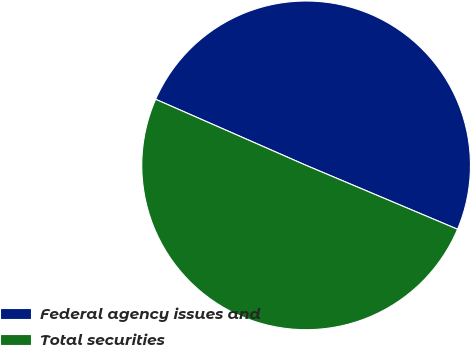Convert chart. <chart><loc_0><loc_0><loc_500><loc_500><pie_chart><fcel>Federal agency issues and<fcel>Total securities<nl><fcel>49.77%<fcel>50.23%<nl></chart> 